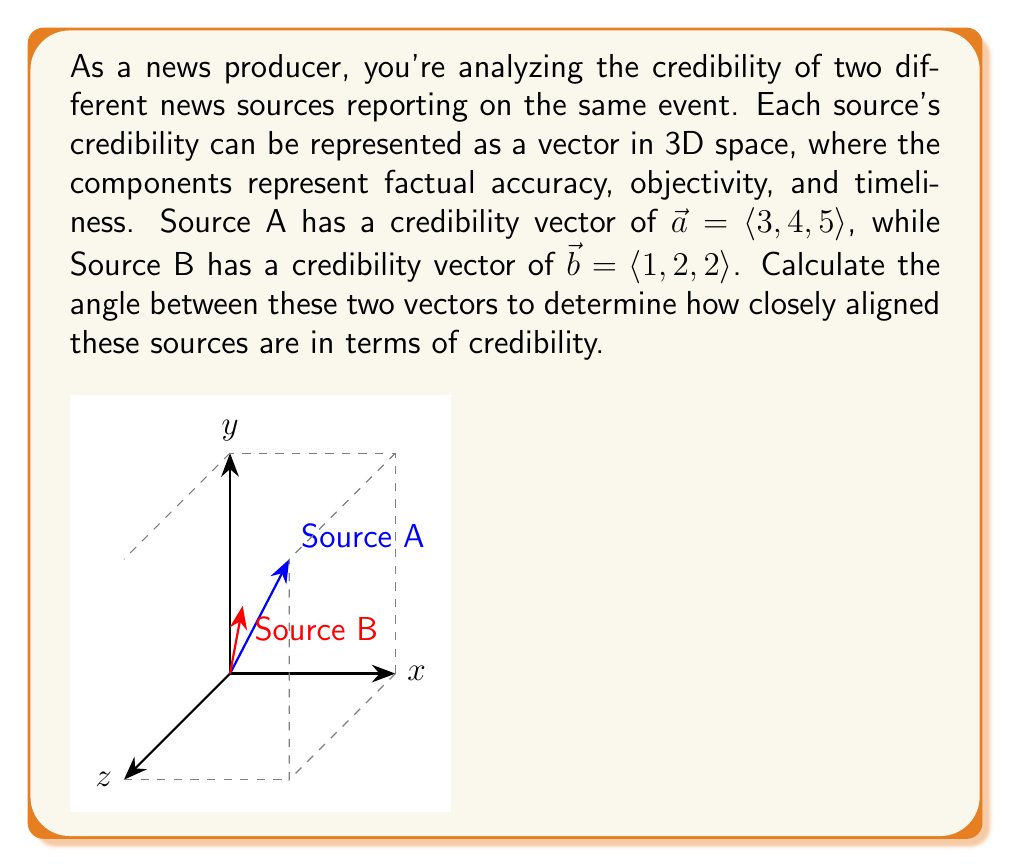Can you answer this question? To find the angle between two vectors, we can use the dot product formula:

$$\cos \theta = \frac{\vec{a} \cdot \vec{b}}{|\vec{a}| |\vec{b}|}$$

Let's solve this step-by-step:

1) First, calculate the dot product $\vec{a} \cdot \vec{b}$:
   $$\vec{a} \cdot \vec{b} = (3)(1) + (4)(2) + (5)(2) = 3 + 8 + 10 = 21$$

2) Calculate the magnitudes of the vectors:
   $$|\vec{a}| = \sqrt{3^2 + 4^2 + 5^2} = \sqrt{9 + 16 + 25} = \sqrt{50}$$
   $$|\vec{b}| = \sqrt{1^2 + 2^2 + 2^2} = \sqrt{1 + 4 + 4} = 3$$

3) Substitute these values into the formula:
   $$\cos \theta = \frac{21}{(\sqrt{50})(3)}$$

4) Simplify:
   $$\cos \theta = \frac{21}{3\sqrt{50}} = \frac{7}{\sqrt{50}}$$

5) To find $\theta$, take the inverse cosine (arccos) of both sides:
   $$\theta = \arccos(\frac{7}{\sqrt{50}})$$

6) Calculate the result (rounded to two decimal places):
   $$\theta \approx 0.41 \text{ radians}$$

7) Convert to degrees:
   $$\theta \approx 0.41 \times \frac{180}{\pi} \approx 23.50°$$
Answer: $23.50°$ 